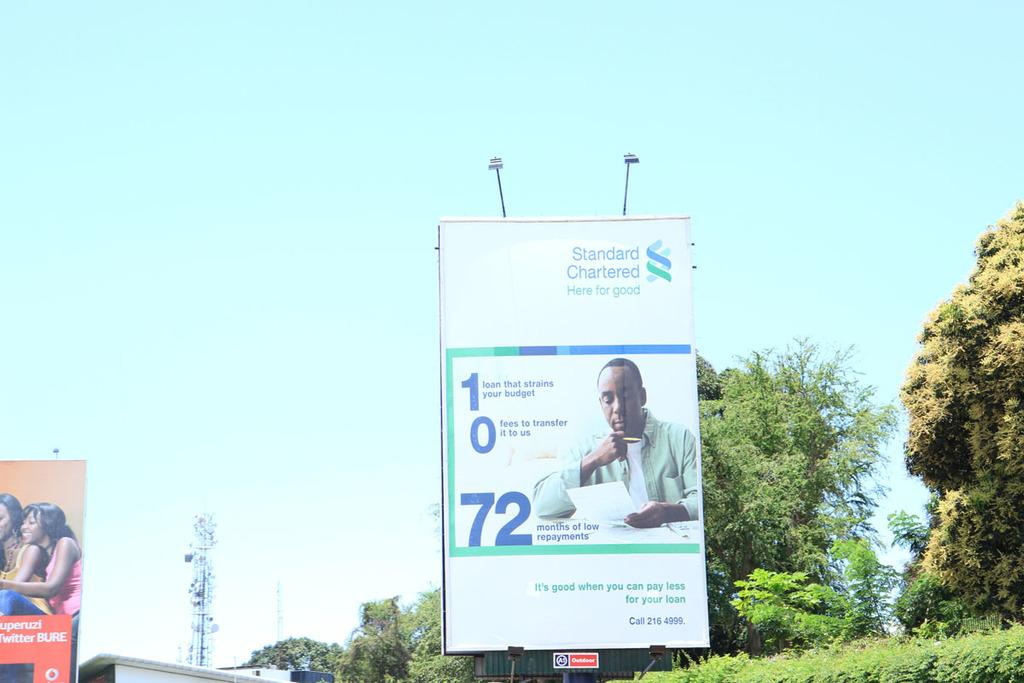Provide a one-sentence caption for the provided image. A bank billboard offers 72 months of low repayments. 